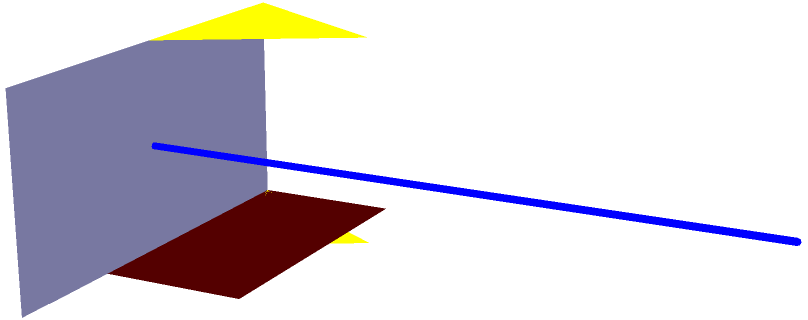Match the 3D projections of the legal objects to their corresponding 2D shadows. Which shadow (A, B, C, or D) corresponds to the gavel? To solve this problem, we need to analyze each 3D object and its corresponding 2D shadow:

1. The gavel consists of a rectangular head and a long handle. Its shadow would show a long, straight line (the handle) connected to a rectangle (the head).

2. The scales of justice are triangular in shape, with two plates suspended from the top point. Its shadow would appear as an inverted triangle.

3. The base is a rectangular prism, which would cast a rectangular shadow.

4. The shadow labeled A shows a rectangular shape connected to a long, straight line. This matches the description of the gavel's shadow.

5. Shadow B appears to be an inverted triangle, which corresponds to the scales of justice.

6. Shadow C is a simple rectangle, matching the base's projection.

7. Shadow D doesn't clearly correspond to any of the 3D objects shown.

Therefore, by process of elimination and matching the characteristics of the gavel to its projected shadow, we can conclude that shadow A corresponds to the gavel.
Answer: A 